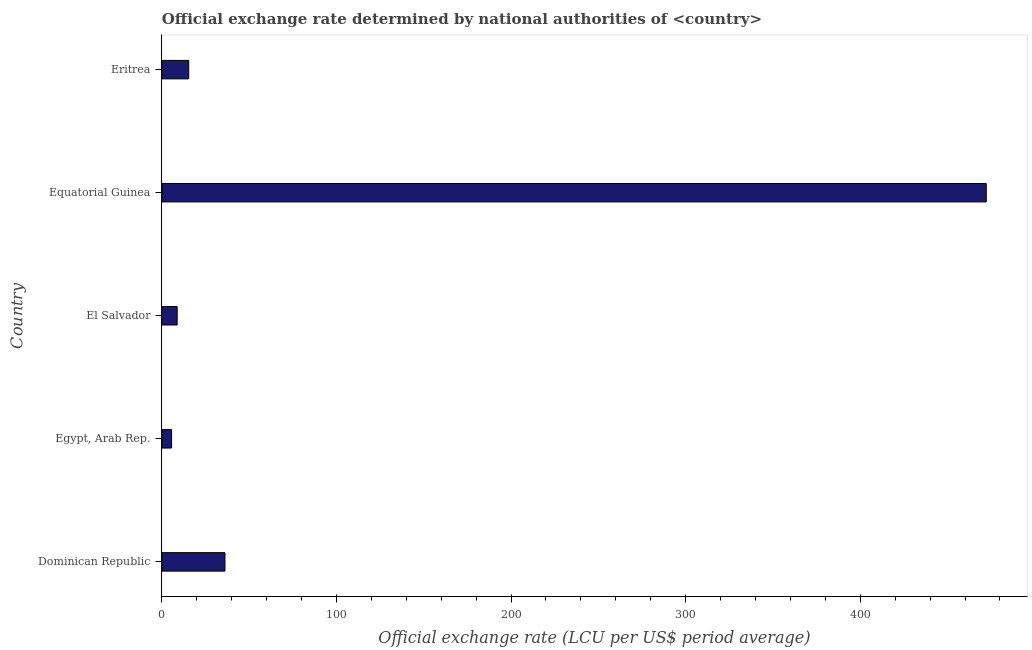What is the title of the graph?
Offer a very short reply. Official exchange rate determined by national authorities of <country>. What is the label or title of the X-axis?
Offer a very short reply. Official exchange rate (LCU per US$ period average). What is the official exchange rate in Eritrea?
Keep it short and to the point. 15.38. Across all countries, what is the maximum official exchange rate?
Give a very brief answer. 472.19. Across all countries, what is the minimum official exchange rate?
Give a very brief answer. 5.54. In which country was the official exchange rate maximum?
Provide a short and direct response. Equatorial Guinea. In which country was the official exchange rate minimum?
Ensure brevity in your answer.  Egypt, Arab Rep. What is the sum of the official exchange rate?
Offer a very short reply. 537.97. What is the difference between the official exchange rate in Egypt, Arab Rep. and El Salvador?
Offer a terse response. -3.21. What is the average official exchange rate per country?
Offer a terse response. 107.59. What is the median official exchange rate?
Provide a short and direct response. 15.38. In how many countries, is the official exchange rate greater than 80 ?
Your response must be concise. 1. What is the ratio of the official exchange rate in El Salvador to that in Equatorial Guinea?
Provide a short and direct response. 0.02. What is the difference between the highest and the second highest official exchange rate?
Offer a very short reply. 436.07. Is the sum of the official exchange rate in Dominican Republic and Equatorial Guinea greater than the maximum official exchange rate across all countries?
Keep it short and to the point. Yes. What is the difference between the highest and the lowest official exchange rate?
Provide a succinct answer. 466.64. Are all the bars in the graph horizontal?
Provide a succinct answer. Yes. How many countries are there in the graph?
Ensure brevity in your answer.  5. What is the difference between two consecutive major ticks on the X-axis?
Offer a terse response. 100. What is the Official exchange rate (LCU per US$ period average) in Dominican Republic?
Offer a very short reply. 36.11. What is the Official exchange rate (LCU per US$ period average) of Egypt, Arab Rep.?
Make the answer very short. 5.54. What is the Official exchange rate (LCU per US$ period average) in El Salvador?
Offer a terse response. 8.75. What is the Official exchange rate (LCU per US$ period average) of Equatorial Guinea?
Offer a very short reply. 472.19. What is the Official exchange rate (LCU per US$ period average) in Eritrea?
Your answer should be compact. 15.38. What is the difference between the Official exchange rate (LCU per US$ period average) in Dominican Republic and Egypt, Arab Rep.?
Your response must be concise. 30.57. What is the difference between the Official exchange rate (LCU per US$ period average) in Dominican Republic and El Salvador?
Provide a short and direct response. 27.36. What is the difference between the Official exchange rate (LCU per US$ period average) in Dominican Republic and Equatorial Guinea?
Offer a very short reply. -436.07. What is the difference between the Official exchange rate (LCU per US$ period average) in Dominican Republic and Eritrea?
Your answer should be compact. 20.74. What is the difference between the Official exchange rate (LCU per US$ period average) in Egypt, Arab Rep. and El Salvador?
Provide a succinct answer. -3.21. What is the difference between the Official exchange rate (LCU per US$ period average) in Egypt, Arab Rep. and Equatorial Guinea?
Provide a short and direct response. -466.64. What is the difference between the Official exchange rate (LCU per US$ period average) in Egypt, Arab Rep. and Eritrea?
Your answer should be very brief. -9.83. What is the difference between the Official exchange rate (LCU per US$ period average) in El Salvador and Equatorial Guinea?
Your answer should be very brief. -463.44. What is the difference between the Official exchange rate (LCU per US$ period average) in El Salvador and Eritrea?
Keep it short and to the point. -6.62. What is the difference between the Official exchange rate (LCU per US$ period average) in Equatorial Guinea and Eritrea?
Provide a succinct answer. 456.81. What is the ratio of the Official exchange rate (LCU per US$ period average) in Dominican Republic to that in Egypt, Arab Rep.?
Your answer should be compact. 6.51. What is the ratio of the Official exchange rate (LCU per US$ period average) in Dominican Republic to that in El Salvador?
Your response must be concise. 4.13. What is the ratio of the Official exchange rate (LCU per US$ period average) in Dominican Republic to that in Equatorial Guinea?
Keep it short and to the point. 0.08. What is the ratio of the Official exchange rate (LCU per US$ period average) in Dominican Republic to that in Eritrea?
Your answer should be compact. 2.35. What is the ratio of the Official exchange rate (LCU per US$ period average) in Egypt, Arab Rep. to that in El Salvador?
Offer a very short reply. 0.63. What is the ratio of the Official exchange rate (LCU per US$ period average) in Egypt, Arab Rep. to that in Equatorial Guinea?
Your answer should be compact. 0.01. What is the ratio of the Official exchange rate (LCU per US$ period average) in Egypt, Arab Rep. to that in Eritrea?
Provide a succinct answer. 0.36. What is the ratio of the Official exchange rate (LCU per US$ period average) in El Salvador to that in Equatorial Guinea?
Make the answer very short. 0.02. What is the ratio of the Official exchange rate (LCU per US$ period average) in El Salvador to that in Eritrea?
Keep it short and to the point. 0.57. What is the ratio of the Official exchange rate (LCU per US$ period average) in Equatorial Guinea to that in Eritrea?
Ensure brevity in your answer.  30.71. 